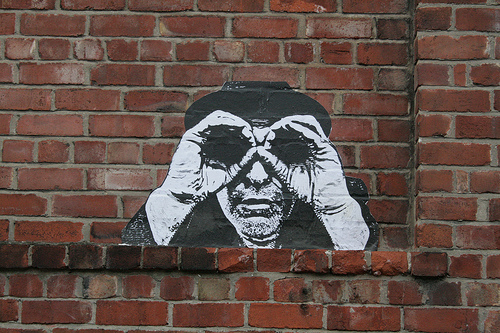<image>
Can you confirm if the brick is on the painted brick? No. The brick is not positioned on the painted brick. They may be near each other, but the brick is not supported by or resting on top of the painted brick. 